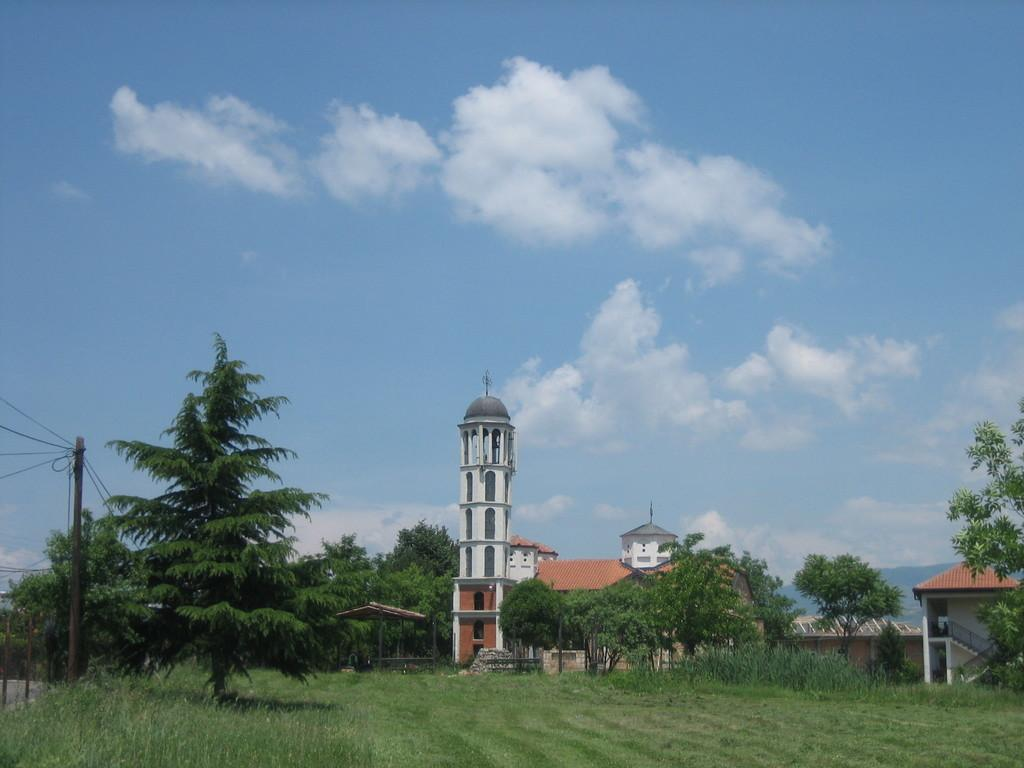What type of vegetation is present in the image? There is grass in the image. What structures can be seen in the image? There are poles, trees, and buildings in the image. What else is present in the image besides vegetation and structures? There are wires in the image. What can be seen in the background of the image? The sky is visible in the background of the image, and there are clouds in the sky. How many tickets are visible in the image? There are no tickets present in the image. What type of room can be seen in the image? There is no room visible in the image; it features an outdoor scene with grass, poles, trees, buildings, wires, and a sky with clouds. 